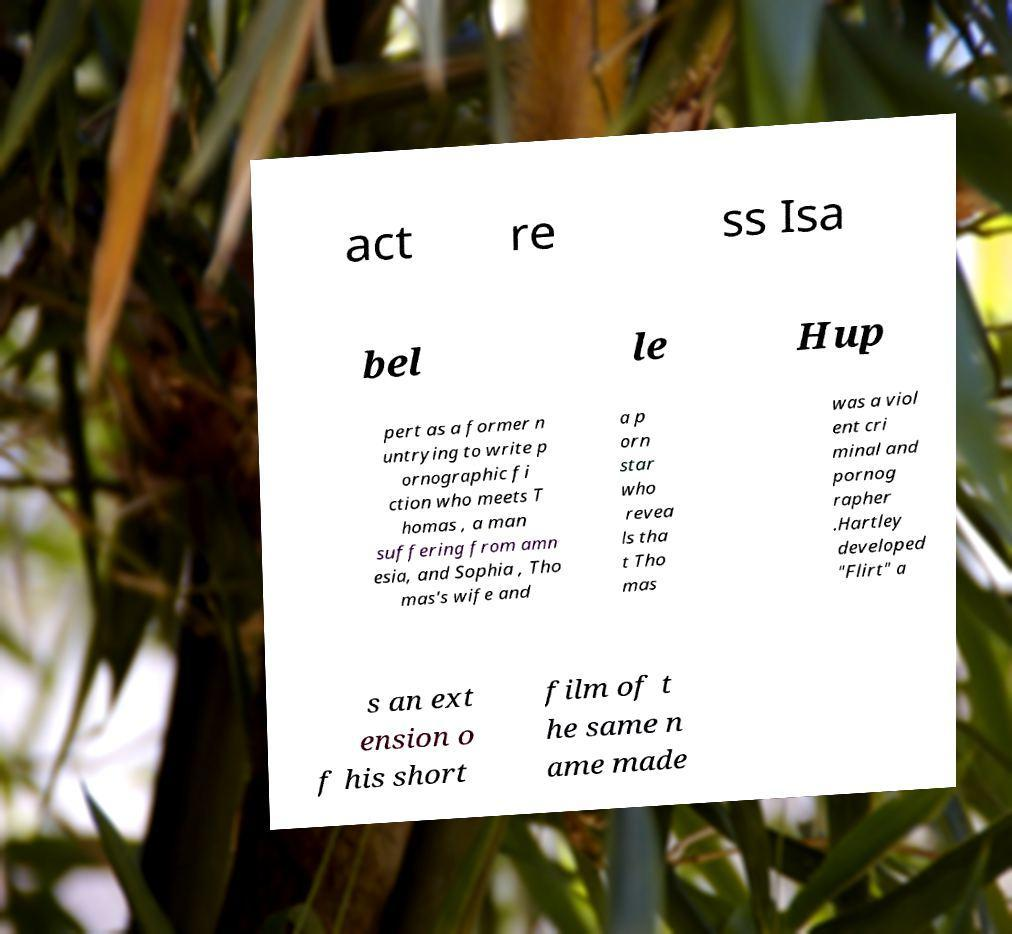Can you read and provide the text displayed in the image?This photo seems to have some interesting text. Can you extract and type it out for me? act re ss Isa bel le Hup pert as a former n untrying to write p ornographic fi ction who meets T homas , a man suffering from amn esia, and Sophia , Tho mas's wife and a p orn star who revea ls tha t Tho mas was a viol ent cri minal and pornog rapher .Hartley developed "Flirt" a s an ext ension o f his short film of t he same n ame made 